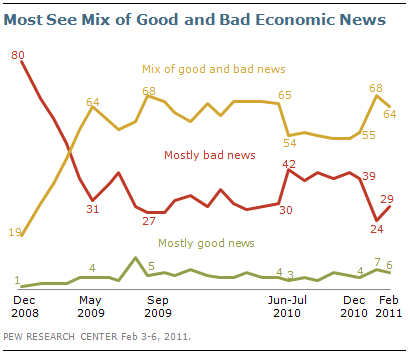What's the add up value of highest value of green and highest value of orange line? To find the sum of the highest values from the green and orange lines on the chart, we must identify the peaks for each. The green line, which represents 'Mostly good news,' peaks at 31 in December 2008. The orange line, depicting 'Mostly bad news,' has its highest point at 68 in May 2009. Adding these together gives us a total of 99. 